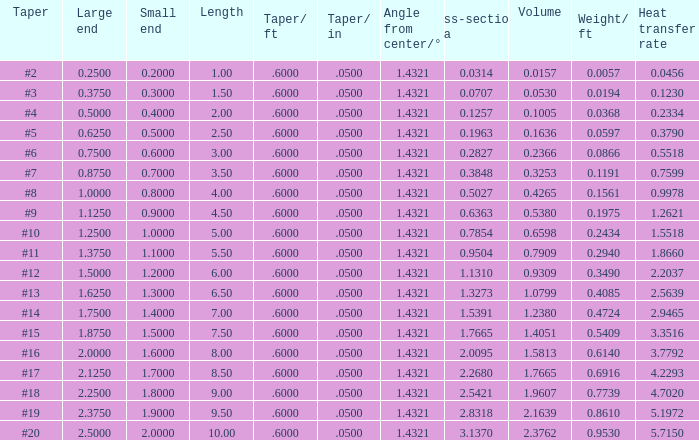Which Large end has a Taper/ft smaller than 0.6000000000000001? 19.0. 